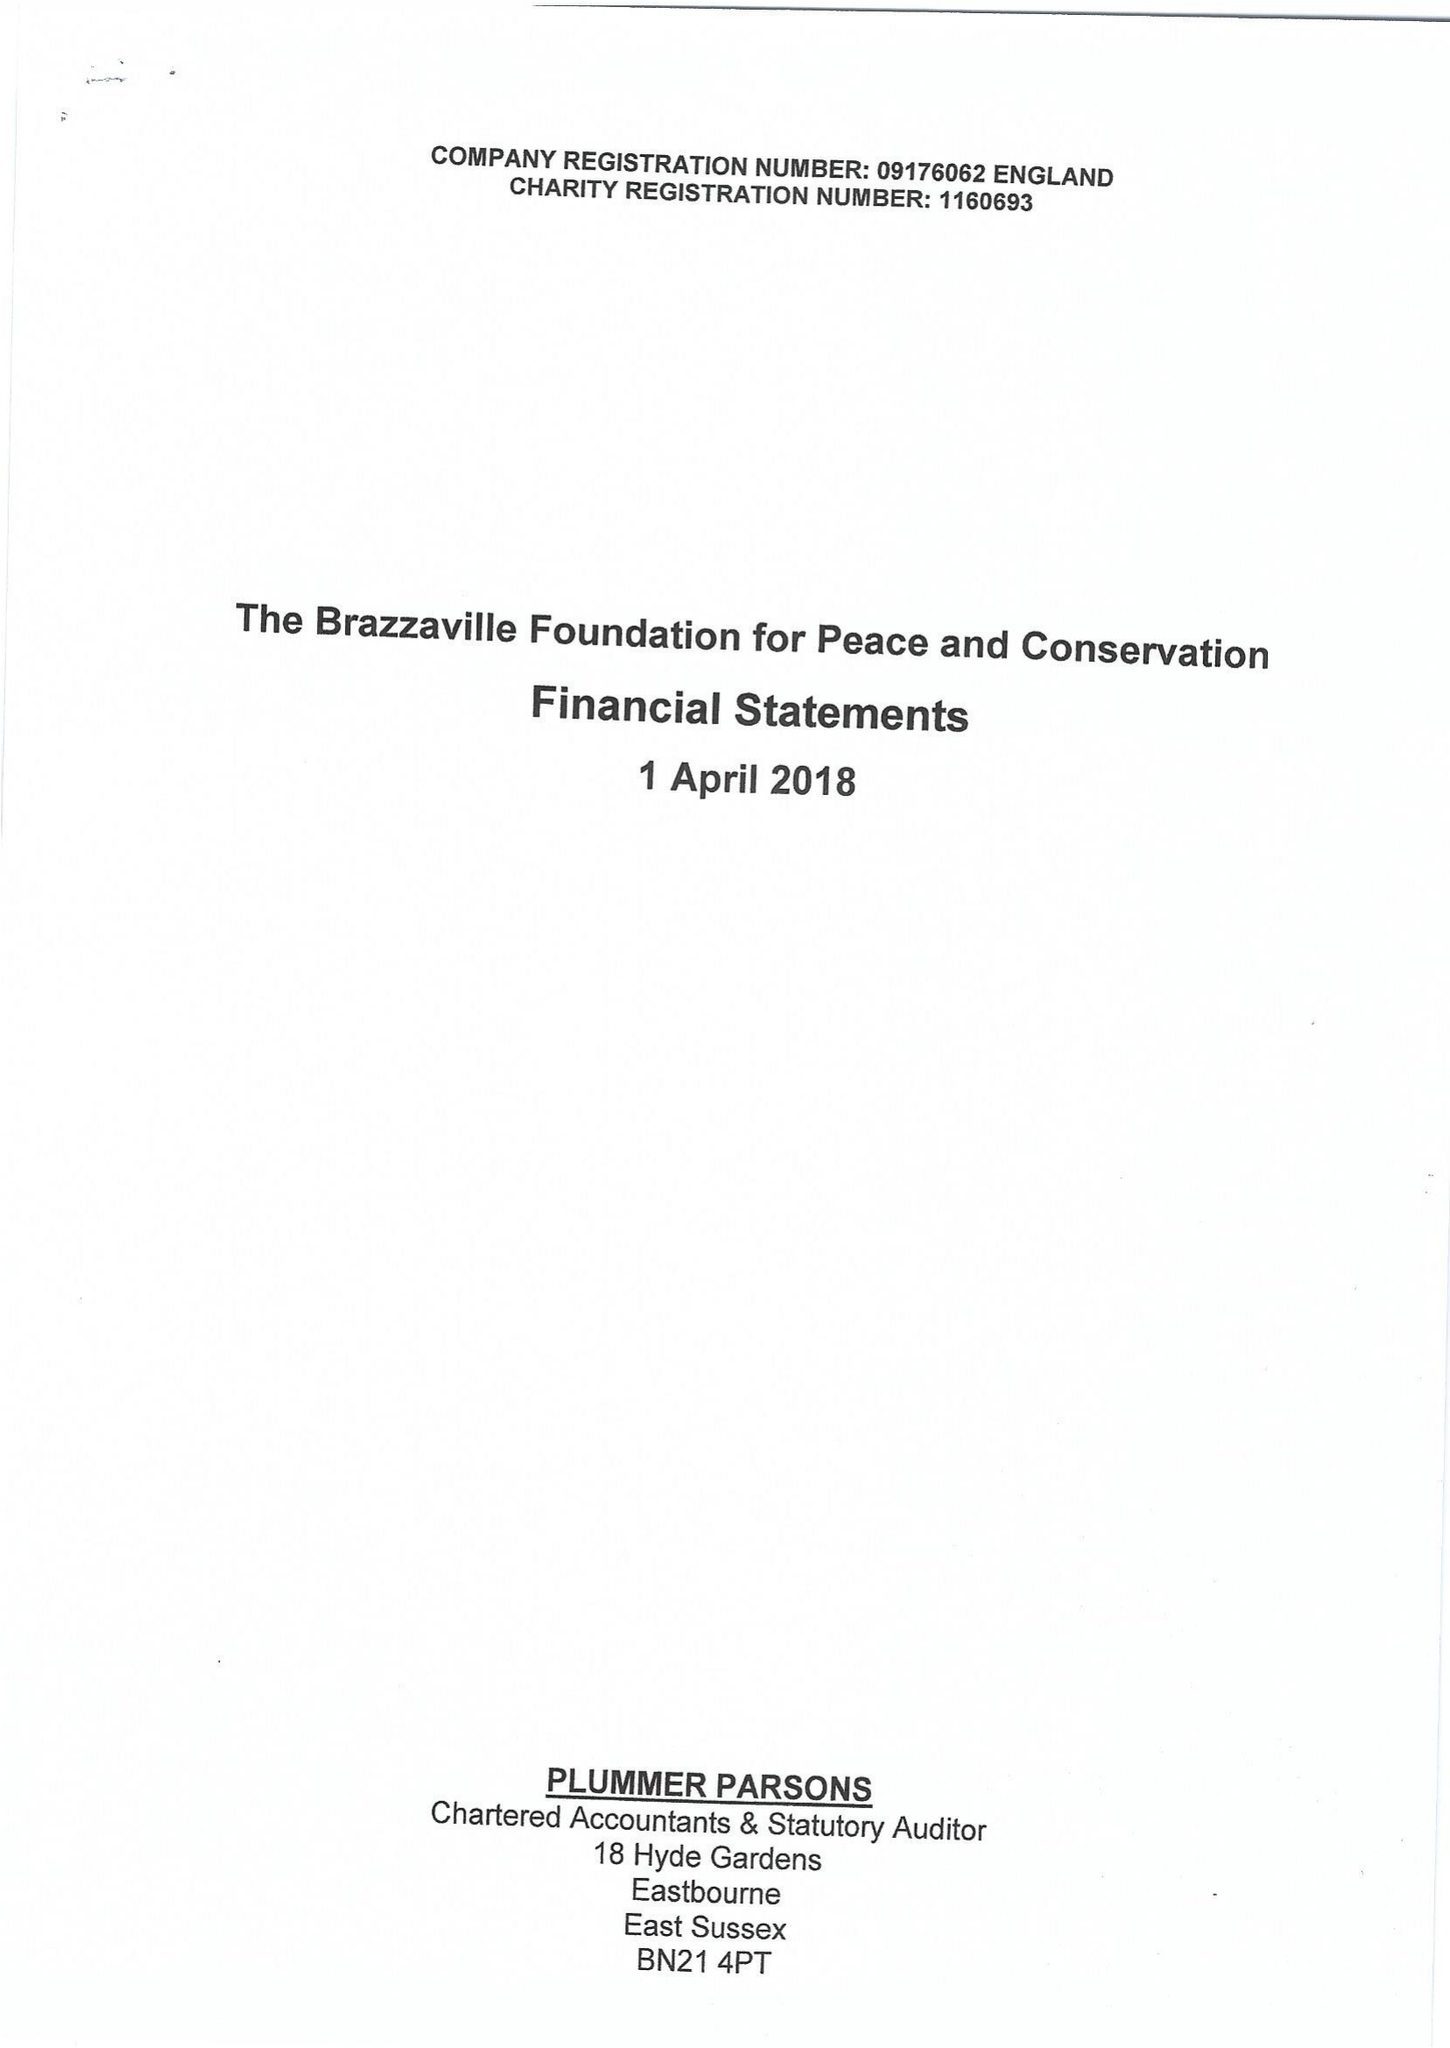What is the value for the address__postcode?
Answer the question using a single word or phrase. EC4R 1BE 